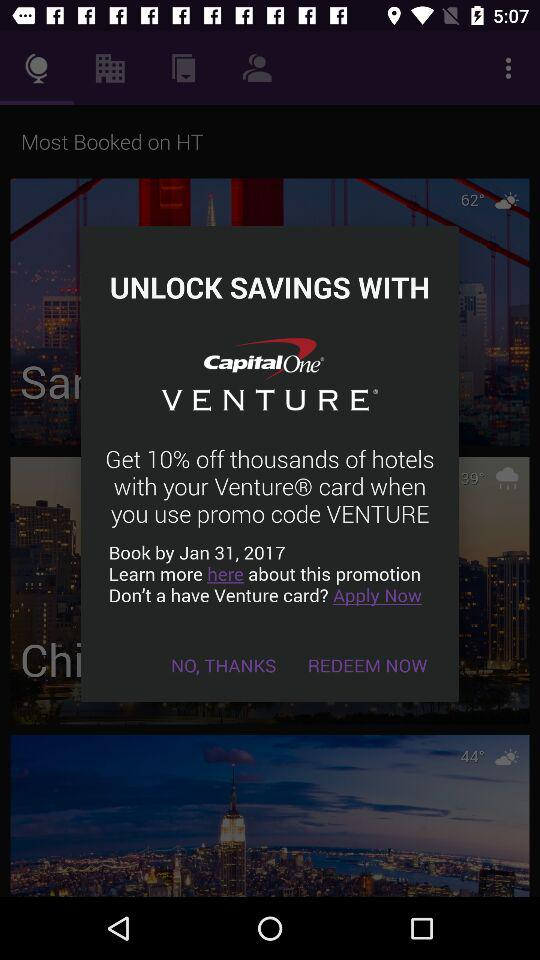How much do we get off on venture cards? You get 10% off on venture cards. 